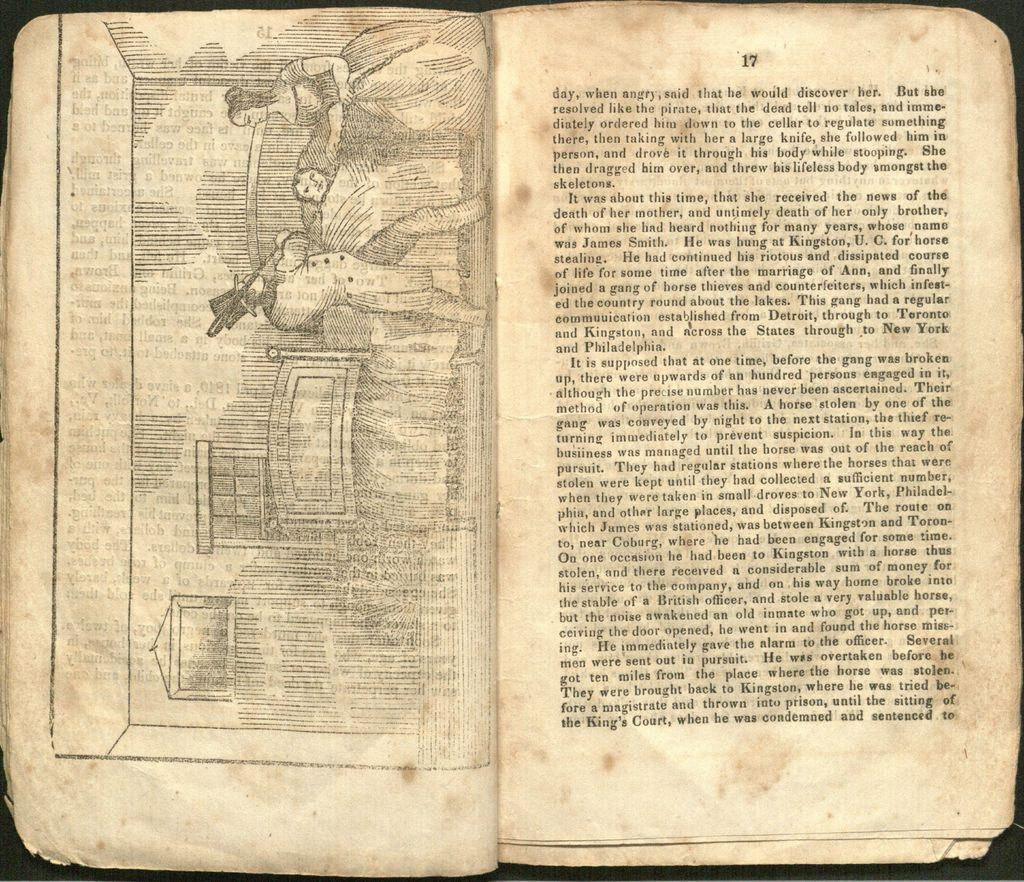<image>
Provide a brief description of the given image. An old book is open to page 17. 